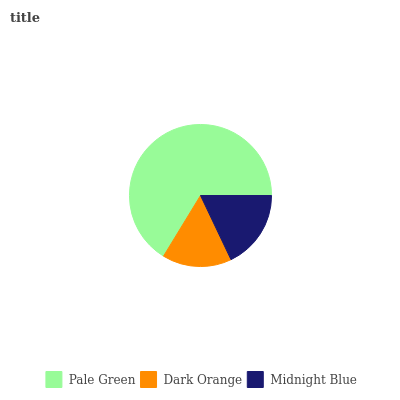Is Dark Orange the minimum?
Answer yes or no. Yes. Is Pale Green the maximum?
Answer yes or no. Yes. Is Midnight Blue the minimum?
Answer yes or no. No. Is Midnight Blue the maximum?
Answer yes or no. No. Is Midnight Blue greater than Dark Orange?
Answer yes or no. Yes. Is Dark Orange less than Midnight Blue?
Answer yes or no. Yes. Is Dark Orange greater than Midnight Blue?
Answer yes or no. No. Is Midnight Blue less than Dark Orange?
Answer yes or no. No. Is Midnight Blue the high median?
Answer yes or no. Yes. Is Midnight Blue the low median?
Answer yes or no. Yes. Is Pale Green the high median?
Answer yes or no. No. Is Pale Green the low median?
Answer yes or no. No. 